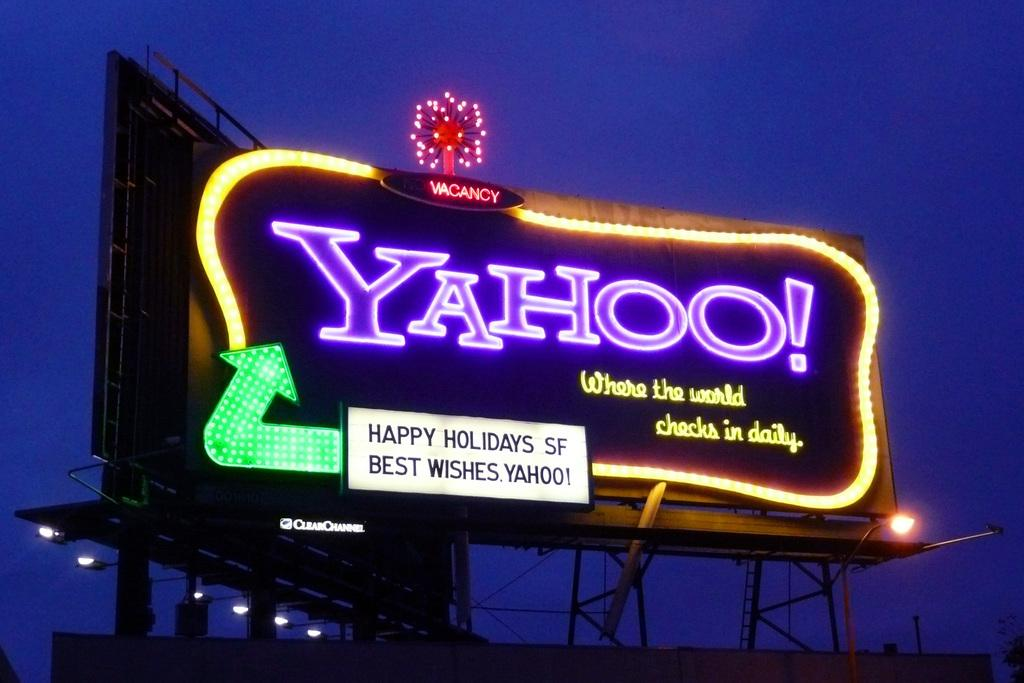<image>
Present a compact description of the photo's key features. A billboard of Yahoo to wish the people a happy holidays. 